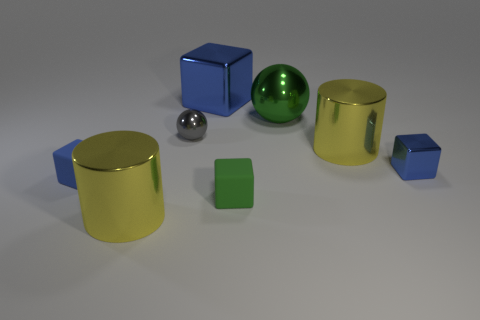How many blue blocks must be subtracted to get 1 blue blocks? 2 Subtract all brown balls. How many blue cubes are left? 3 Subtract all big cubes. How many cubes are left? 3 Subtract all red cubes. Subtract all green cylinders. How many cubes are left? 4 Add 1 big metal cylinders. How many objects exist? 9 Subtract all spheres. How many objects are left? 6 Add 3 big green shiny objects. How many big green shiny objects are left? 4 Add 8 large spheres. How many large spheres exist? 9 Subtract 0 red cylinders. How many objects are left? 8 Subtract all large yellow matte spheres. Subtract all blue shiny objects. How many objects are left? 6 